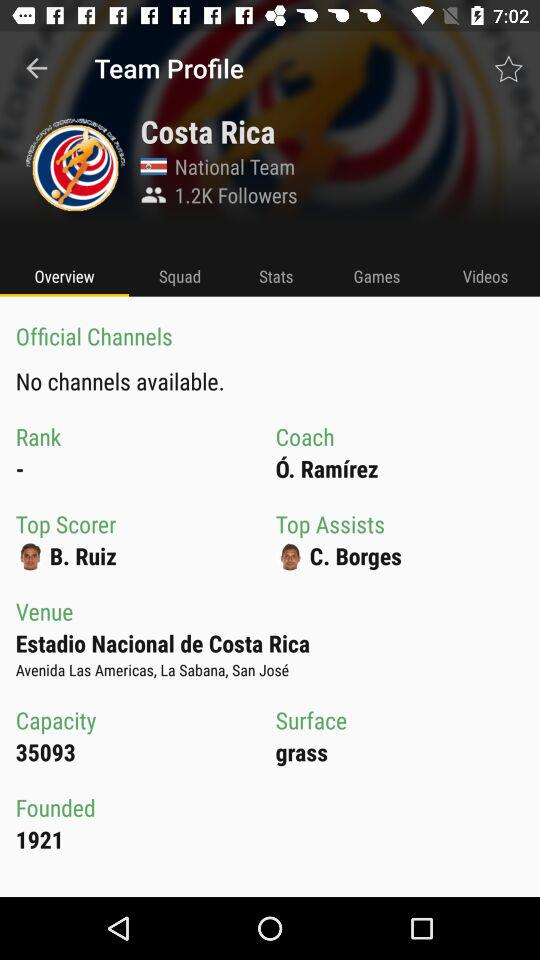What is the capacity of the ground? The capacity of the ground is 35093. 